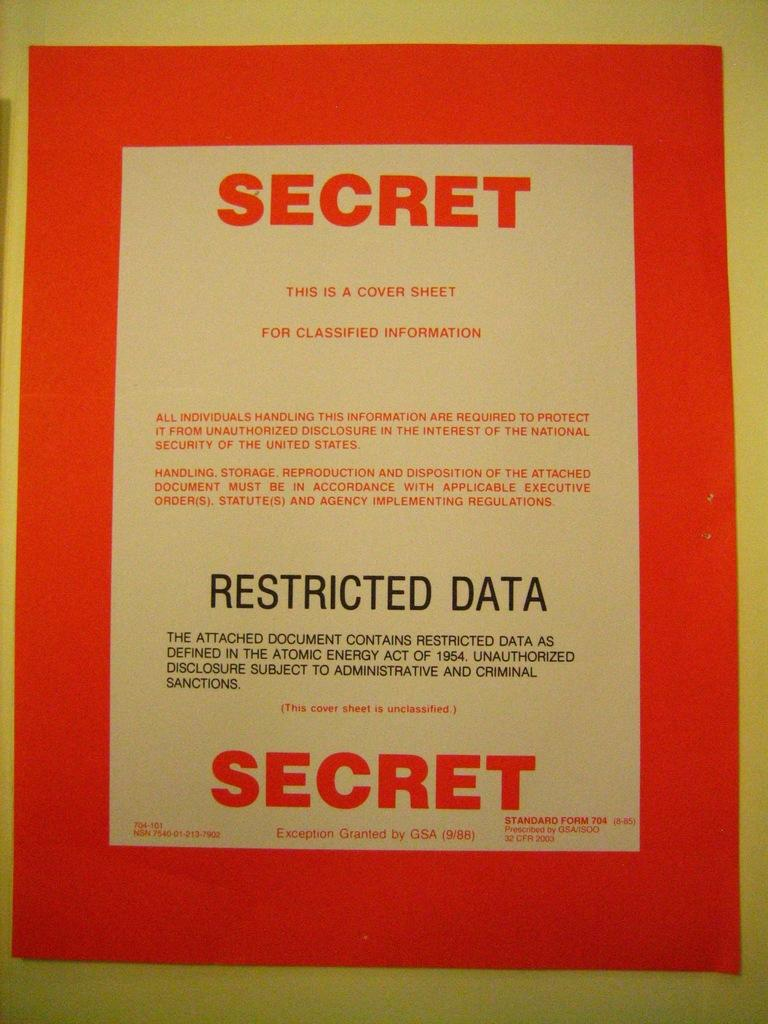Provide a one-sentence caption for the provided image. A manila envelope with an orange label on it stating Secret for classified information. 